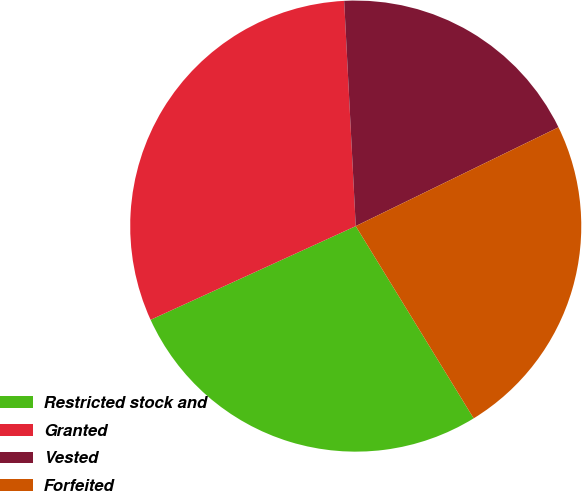Convert chart. <chart><loc_0><loc_0><loc_500><loc_500><pie_chart><fcel>Restricted stock and<fcel>Granted<fcel>Vested<fcel>Forfeited<nl><fcel>26.94%<fcel>31.0%<fcel>18.6%<fcel>23.46%<nl></chart> 